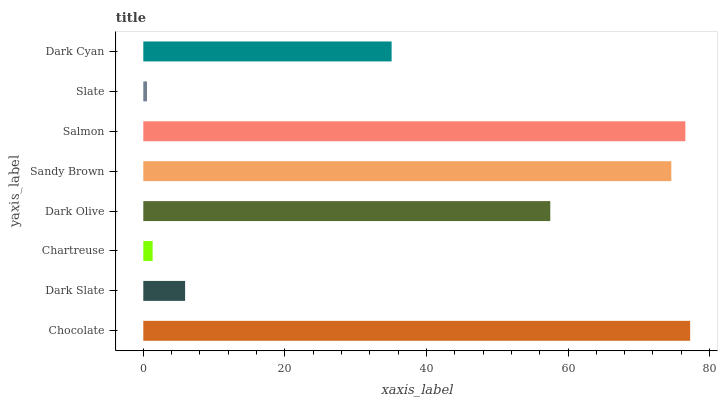Is Slate the minimum?
Answer yes or no. Yes. Is Chocolate the maximum?
Answer yes or no. Yes. Is Dark Slate the minimum?
Answer yes or no. No. Is Dark Slate the maximum?
Answer yes or no. No. Is Chocolate greater than Dark Slate?
Answer yes or no. Yes. Is Dark Slate less than Chocolate?
Answer yes or no. Yes. Is Dark Slate greater than Chocolate?
Answer yes or no. No. Is Chocolate less than Dark Slate?
Answer yes or no. No. Is Dark Olive the high median?
Answer yes or no. Yes. Is Dark Cyan the low median?
Answer yes or no. Yes. Is Dark Cyan the high median?
Answer yes or no. No. Is Dark Slate the low median?
Answer yes or no. No. 